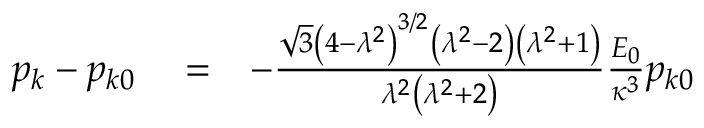<formula> <loc_0><loc_0><loc_500><loc_500>\begin{array} { r l r } { p _ { k } - p _ { k 0 } } & = } & { - \frac { \sqrt { 3 } \left ( 4 - \lambda ^ { 2 } \right ) ^ { 3 / 2 } \left ( \lambda ^ { 2 } - 2 \right ) \left ( \lambda ^ { 2 } + 1 \right ) } { \lambda ^ { 2 } \left ( \lambda ^ { 2 } + 2 \right ) } \frac { E _ { 0 } } { \kappa ^ { 3 } } p _ { k 0 } } \end{array}</formula> 